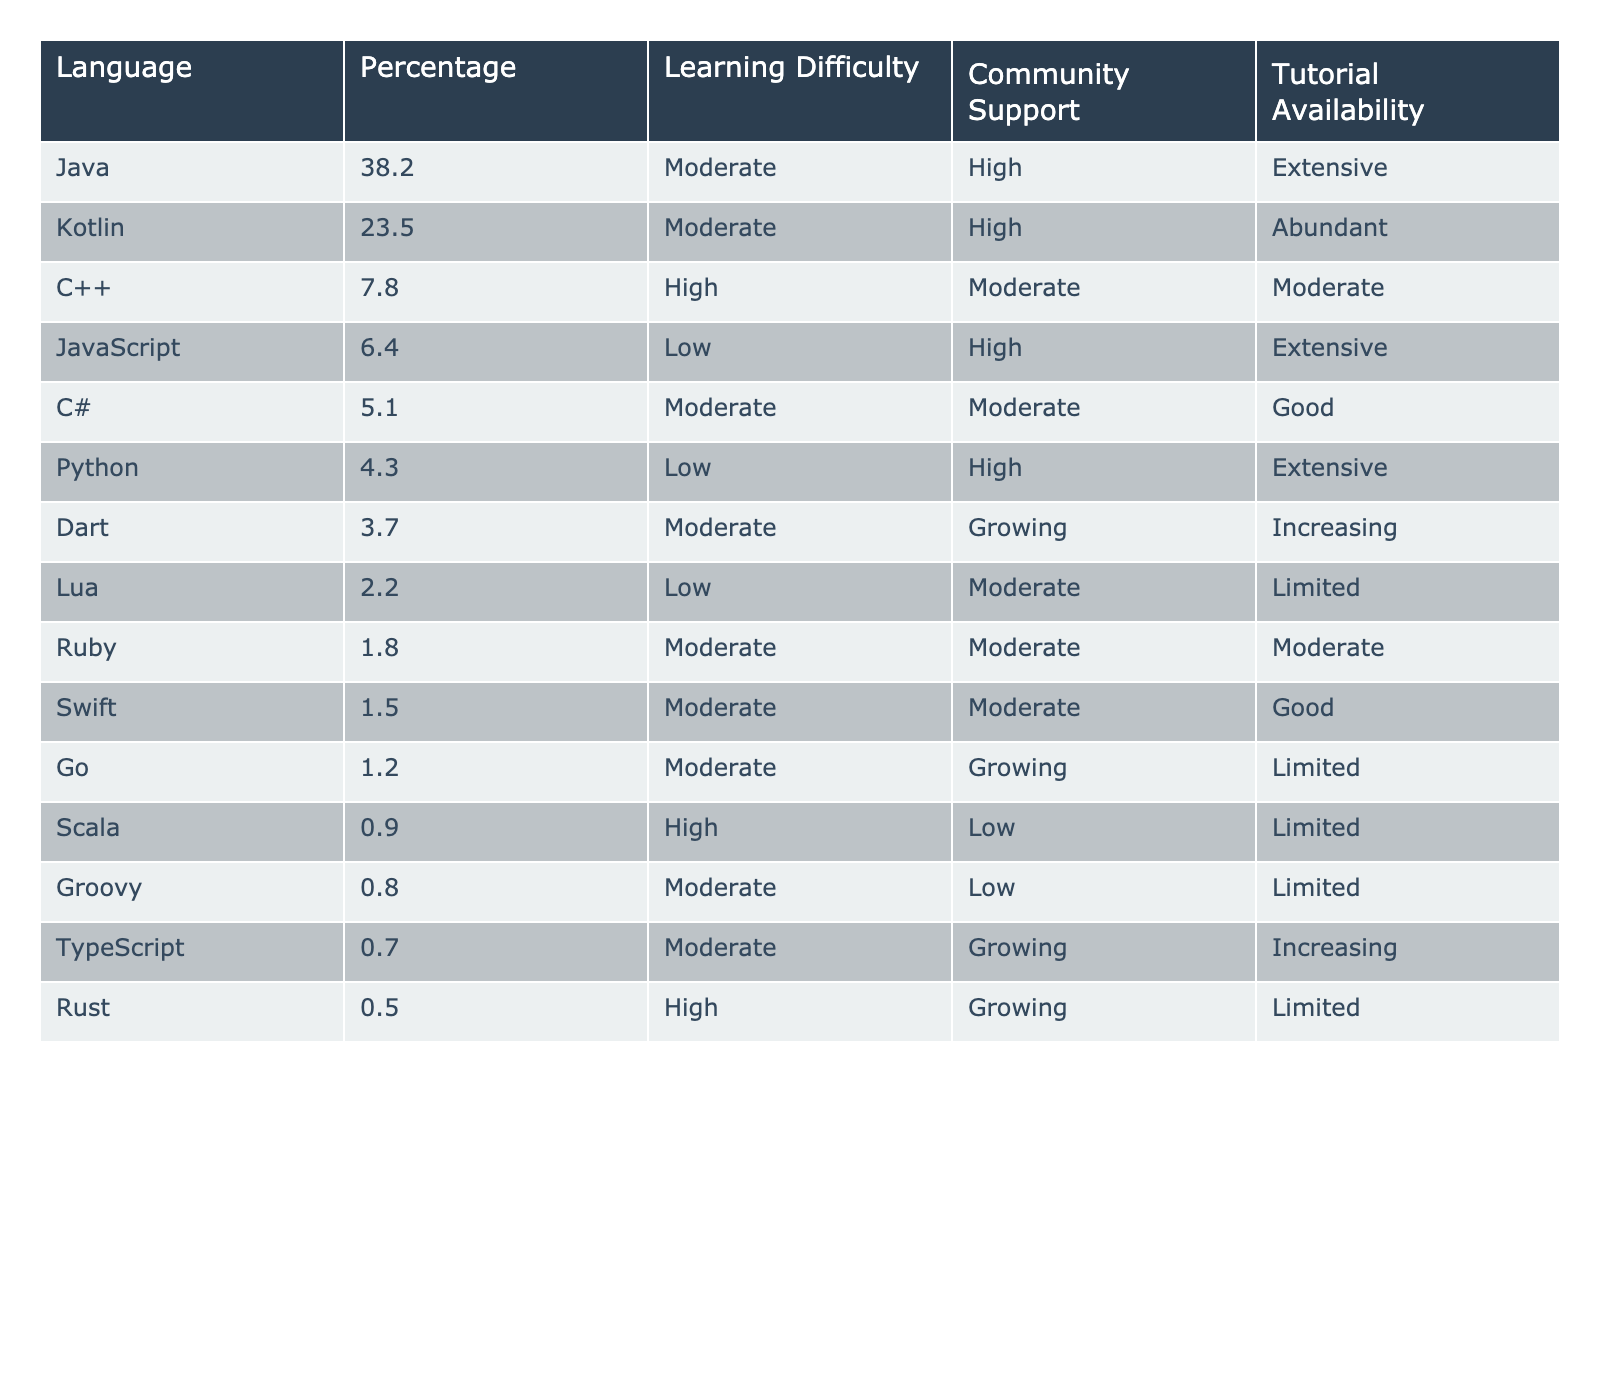What is the most popular Android programming language? By reviewing the "Percentage" column, the language with the highest percentage is Java at 38.2%.
Answer: Java Which programming language has the least community support? Looking at the "Community Support" column, Scala has the lowest rating with "Low" support.
Answer: Scala What is the learning difficulty of C++? The table lists C++ under the "Learning Difficulty" column with a rating of "High."
Answer: High What is the percentage of use for Kotlin compared to C#? Kotlin has a usage percentage of 23.5%, while C# has 5.1%. The difference is 23.5 - 5.1 = 18.4%.
Answer: 18.4% Are Python and JavaScript considered to have low learning difficulty? Python has a "Low" learning difficulty, while JavaScript also has a "Low" rating, confirming both languages fit that description.
Answer: Yes Which two languages have similar percentages of usage with respect to each other, specifically between Dart and Lua? Dart has a 3.7% usage while Lua is at 2.2%, and when comparing these, Dart is greater by 1.5%.
Answer: Dart is greater by 1.5% What is the total percentage usage of Kotlin, C++, and Java together? Adding these percentages: Kotlin (23.5) + C++ (7.8) + Java (38.2) gives a total of 69.5%.
Answer: 69.5% Is Dart more popular than Python according to the usage statistics? Dart has a percentage of 3.7%, and Python has 4.3%; since 3.7% is less than 4.3%, Dart is not more popular.
Answer: No Which languages have "Growing" community support? By checking the "Community Support" column, Dart, Go, and Rust have been rated as "Growing."
Answer: Dart, Go, Rust What is the average usage percentage of languages with "Moderate" learning difficulty? The percentage values for languages with "Moderate" difficulty are Java (38.2), Kotlin (23.5), C# (5.1), Dart (3.7), Groovy (0.8), TypeScript (0.7), and Ruby (1.8), totaling up to 73.8%; dividing by the 7 languages gives an average of 73.8 / 7 ≈ 10.54%.
Answer: 10.54% 